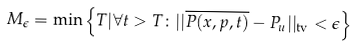Convert formula to latex. <formula><loc_0><loc_0><loc_500><loc_500>M _ { \epsilon } = \min \left \{ T | \forall t > T \colon | | \overline { P ( x , p , t ) } - P _ { u } | | _ { \text {tv} } < \epsilon \right \}</formula> 